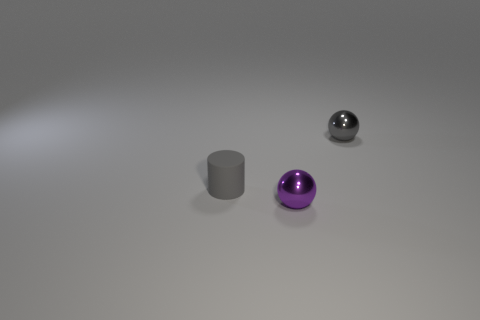Subtract all gray balls. Subtract all green blocks. How many balls are left? 1 Subtract all blue cylinders. How many brown balls are left? 0 Add 1 large objects. How many tiny grays exist? 0 Subtract all gray objects. Subtract all tiny blue metallic spheres. How many objects are left? 1 Add 3 purple balls. How many purple balls are left? 4 Add 2 blue spheres. How many blue spheres exist? 2 Add 3 purple spheres. How many objects exist? 6 Subtract all purple balls. How many balls are left? 1 Subtract 0 green cubes. How many objects are left? 3 Subtract all balls. How many objects are left? 1 